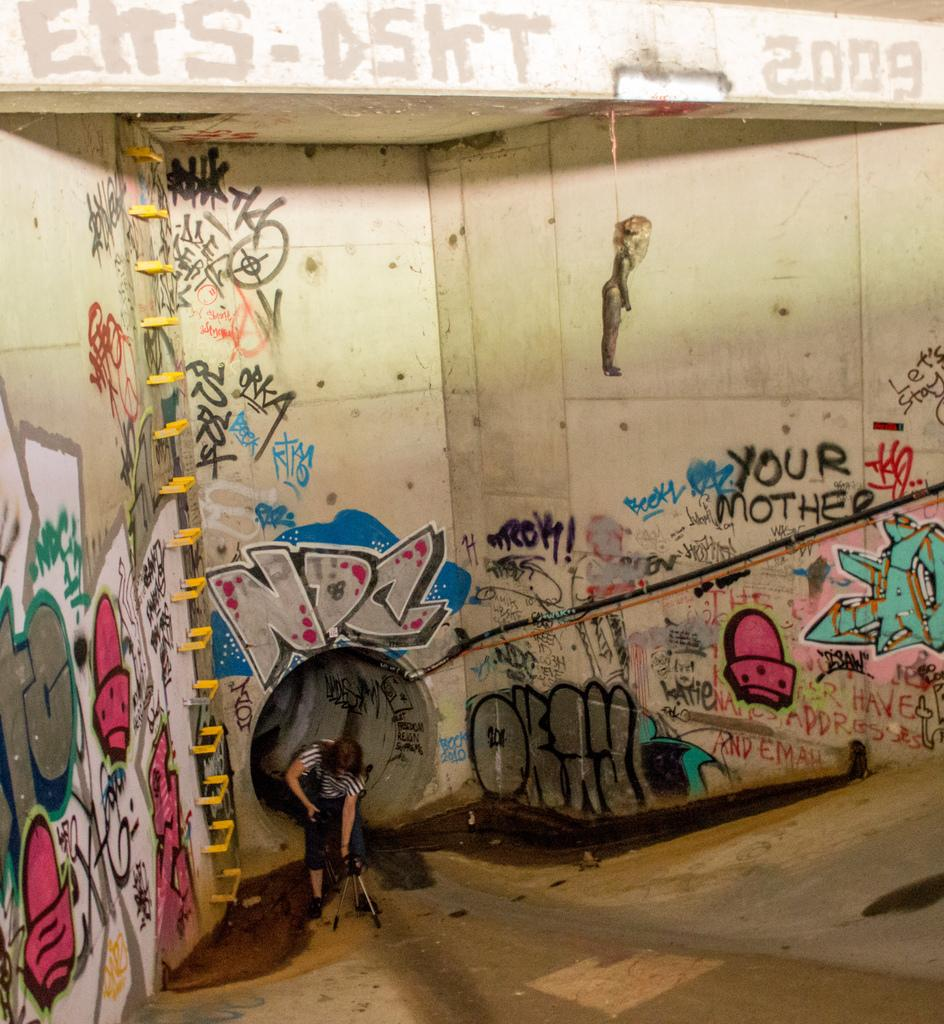What is the person in the image doing? The person is sitting beside a tunnel in the image. What equipment can be seen on the ground in the image? There is a camera with a stand on the ground in the image. What additional items are visible in the image? Ladders and rugs are visible in the image. What can be seen on the walls in the image? There is graffiti on the walls in the image. What type of record is being played in the image? There is no record player or music being played in the image; it only features a person sitting beside a tunnel, a camera with a stand, ladders, rugs, and graffiti on the walls. 